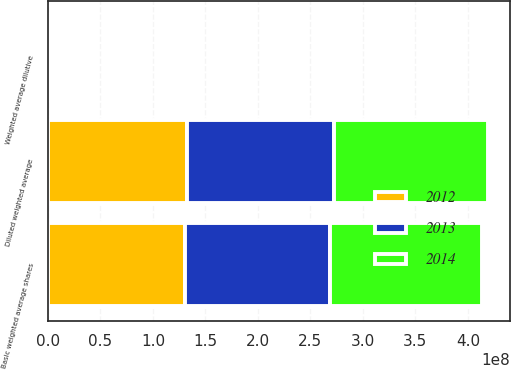Convert chart to OTSL. <chart><loc_0><loc_0><loc_500><loc_500><stacked_bar_chart><ecel><fcel>Basic weighted average shares<fcel>Weighted average dilutive<fcel>Diluted weighted average<nl><fcel>2012<fcel>1.30722e+08<fcel>1.91851e+06<fcel>1.3264e+08<nl><fcel>2013<fcel>1.37647e+08<fcel>1.9169e+06<fcel>1.39564e+08<nl><fcel>2014<fcel>1.44921e+08<fcel>1.92628e+06<fcel>1.46848e+08<nl></chart> 